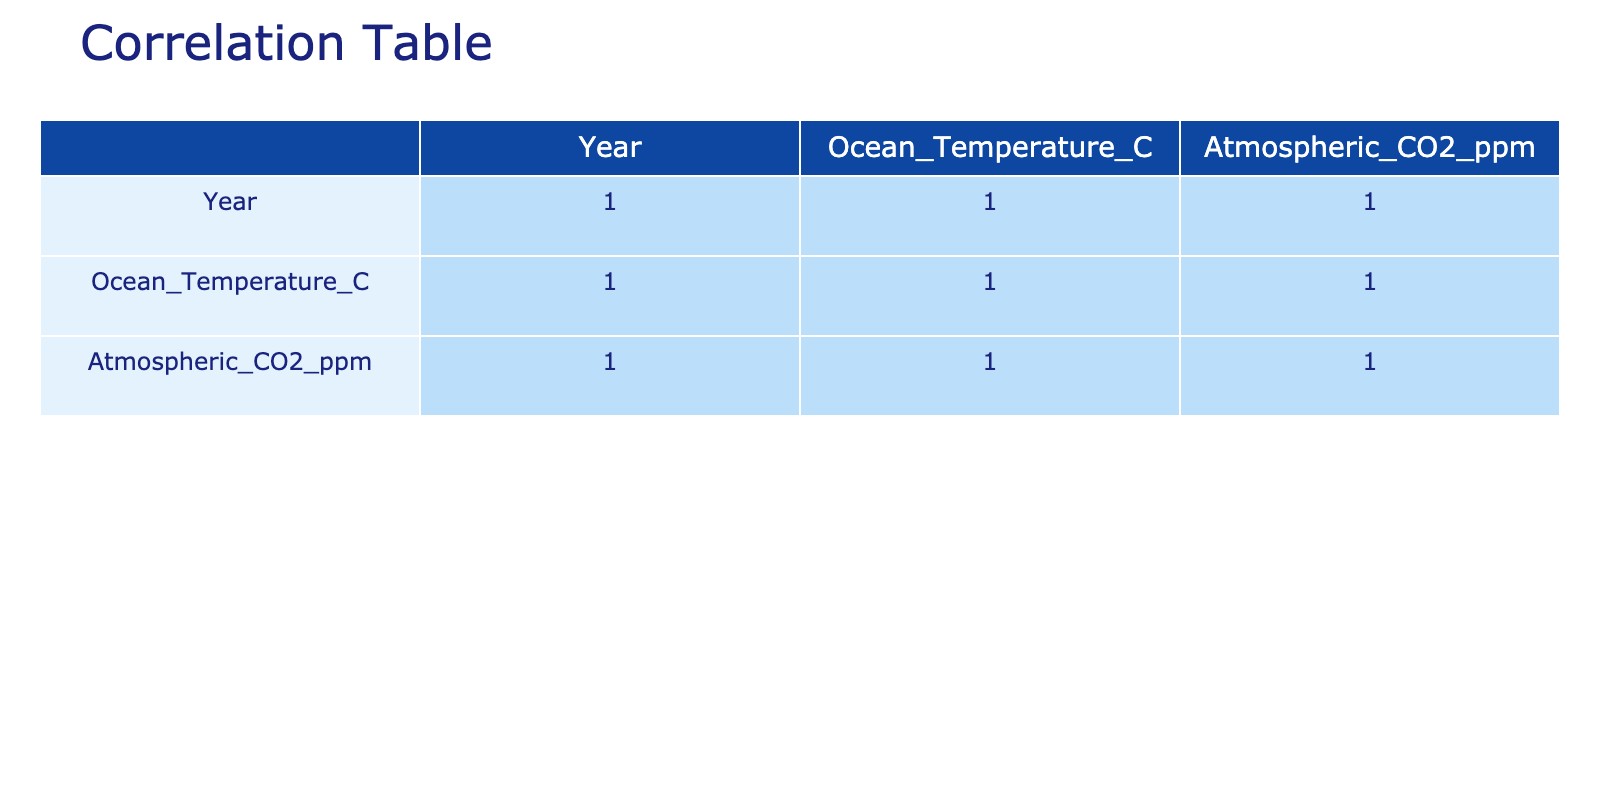What is the correlation coefficient between ocean temperature and atmospheric carbon dioxide levels? From the correlation table, you can look at the row for "Ocean_Temperature_C" and find the column for "Atmospheric_CO2_ppm," which shows the correlation coefficient to be approximately 0.98. This indicates a very strong positive correlation.
Answer: 0.98 In which year did the ocean temperature first exceed 18 degrees Celsius? By examining the values of ocean temperature over the years, you see that it reached 18 degrees Celsius for the first time in 2005.
Answer: 2005 What is the average increase in atmospheric carbon dioxide levels per year from 1973 to 2023? To calculate the average increase, take the final CO2 level (422 ppm in 2023) and subtract the initial level (325 ppm in 1973), giving 97 ppm. Then, divide by the number of years (50): 97/50 = 1.94 ppm/year.
Answer: 1.94 ppm/year Is there a year when the ocean temperature remained below 14 degrees Celsius? By looking at the table, from the data provided, there is no year when the ocean temperature fell below 14 degrees Celsius, as the lowest recorded temperature during this period is 13.5 degrees Celsius in 1973.
Answer: No Calculate the median ocean temperature from 1973 to 2023. To find the median, arrange the ocean temperatures in ascending order: [13.5, 13.6, 13.7, ..., 21.0]. Since there are 51 values, the median will be the average of the 25th and 26th values (which are 17.2 and 17.3). So, (17.2 + 17.3) / 2 = 17.25.
Answer: 17.25 How does the ocean temperature in 2010 compare to the average ocean temperature from 2000 to 2005? The ocean temperature for 2010 is 18.8 degrees Celsius. The average from 2000 to 2005 is calculated as (17.1 + 17.3 + 17.5 + 17.6 + 17.8 + 18.0) / 6 = 17.68 degrees Celsius. Comparing these, 18.8 is higher than 17.68.
Answer: Higher Is the trend of ocean temperature over the years increasing? Reviewing the correlation and values in the table, the ocean temperatures are consistently rising each year, showing a clear upward trend.
Answer: Yes What was the atmospheric CO2 level in the year when ocean temperature reached 19 degrees Celsius for the first time? The ocean temperature reached 19 degrees Celsius in 2015, and the corresponding CO2 level for that year was 406 ppm.
Answer: 406 ppm 